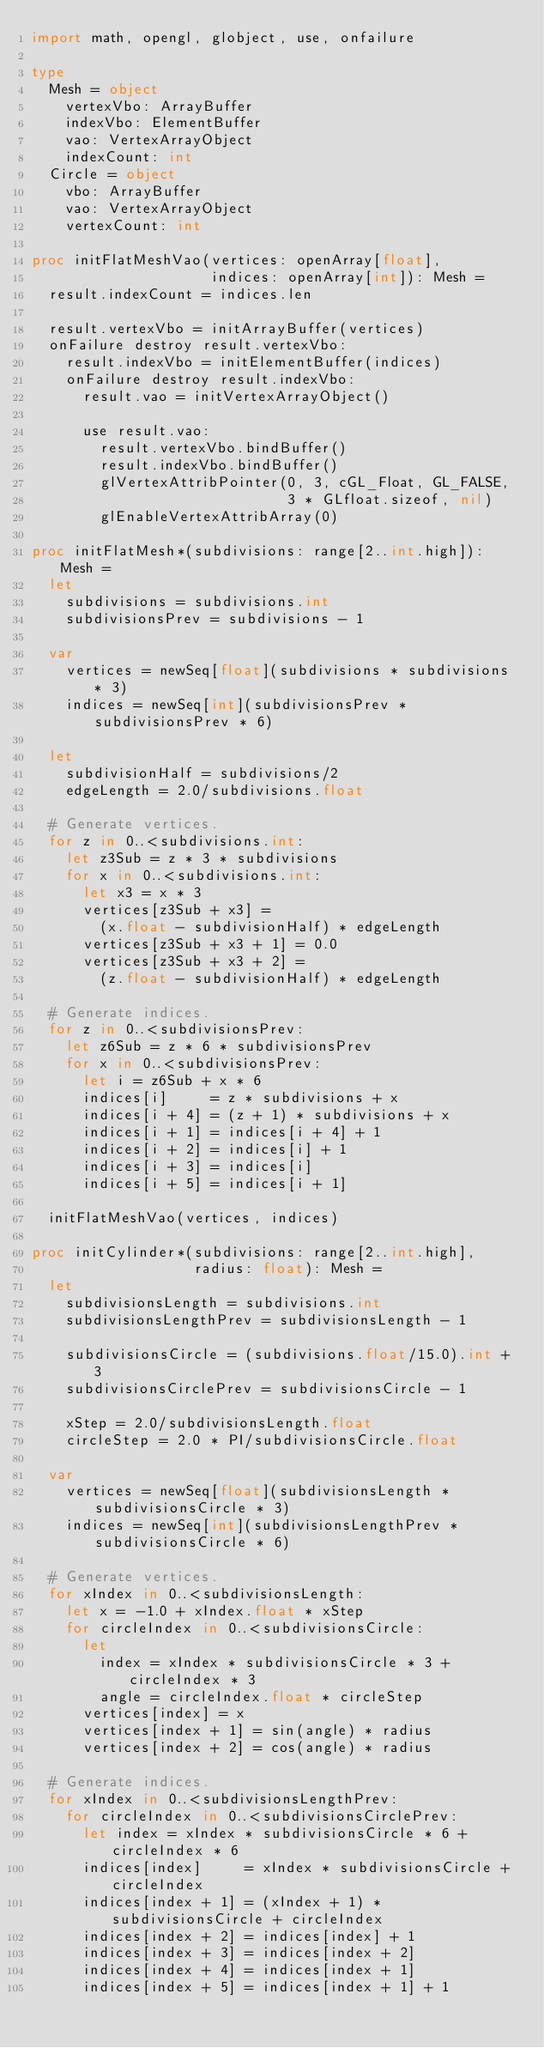Convert code to text. <code><loc_0><loc_0><loc_500><loc_500><_Nim_>import math, opengl, globject, use, onfailure

type
  Mesh = object
    vertexVbo: ArrayBuffer
    indexVbo: ElementBuffer
    vao: VertexArrayObject
    indexCount: int
  Circle = object
    vbo: ArrayBuffer
    vao: VertexArrayObject
    vertexCount: int

proc initFlatMeshVao(vertices: openArray[float],
                     indices: openArray[int]): Mesh =
  result.indexCount = indices.len

  result.vertexVbo = initArrayBuffer(vertices)
  onFailure destroy result.vertexVbo:
    result.indexVbo = initElementBuffer(indices)
    onFailure destroy result.indexVbo:
      result.vao = initVertexArrayObject()

      use result.vao:
        result.vertexVbo.bindBuffer()
        result.indexVbo.bindBuffer()
        glVertexAttribPointer(0, 3, cGL_Float, GL_FALSE,
                              3 * GLfloat.sizeof, nil)
        glEnableVertexAttribArray(0)

proc initFlatMesh*(subdivisions: range[2..int.high]): Mesh =
  let
    subdivisions = subdivisions.int
    subdivisionsPrev = subdivisions - 1

  var
    vertices = newSeq[float](subdivisions * subdivisions * 3)
    indices = newSeq[int](subdivisionsPrev * subdivisionsPrev * 6)

  let
    subdivisionHalf = subdivisions/2
    edgeLength = 2.0/subdivisions.float

  # Generate vertices.
  for z in 0..<subdivisions.int:
    let z3Sub = z * 3 * subdivisions
    for x in 0..<subdivisions.int:
      let x3 = x * 3
      vertices[z3Sub + x3] =
        (x.float - subdivisionHalf) * edgeLength
      vertices[z3Sub + x3 + 1] = 0.0
      vertices[z3Sub + x3 + 2] =
        (z.float - subdivisionHalf) * edgeLength

  # Generate indices.
  for z in 0..<subdivisionsPrev:
    let z6Sub = z * 6 * subdivisionsPrev
    for x in 0..<subdivisionsPrev:
      let i = z6Sub + x * 6
      indices[i]     = z * subdivisions + x
      indices[i + 4] = (z + 1) * subdivisions + x
      indices[i + 1] = indices[i + 4] + 1
      indices[i + 2] = indices[i] + 1
      indices[i + 3] = indices[i]
      indices[i + 5] = indices[i + 1]

  initFlatMeshVao(vertices, indices)

proc initCylinder*(subdivisions: range[2..int.high],
                   radius: float): Mesh =
  let
    subdivisionsLength = subdivisions.int
    subdivisionsLengthPrev = subdivisionsLength - 1

    subdivisionsCircle = (subdivisions.float/15.0).int + 3
    subdivisionsCirclePrev = subdivisionsCircle - 1

    xStep = 2.0/subdivisionsLength.float
    circleStep = 2.0 * PI/subdivisionsCircle.float

  var
    vertices = newSeq[float](subdivisionsLength * subdivisionsCircle * 3)
    indices = newSeq[int](subdivisionsLengthPrev * subdivisionsCircle * 6)

  # Generate vertices.
  for xIndex in 0..<subdivisionsLength:
    let x = -1.0 + xIndex.float * xStep
    for circleIndex in 0..<subdivisionsCircle:
      let
        index = xIndex * subdivisionsCircle * 3 + circleIndex * 3
        angle = circleIndex.float * circleStep
      vertices[index] = x
      vertices[index + 1] = sin(angle) * radius
      vertices[index + 2] = cos(angle) * radius

  # Generate indices.
  for xIndex in 0..<subdivisionsLengthPrev:
    for circleIndex in 0..<subdivisionsCirclePrev:
      let index = xIndex * subdivisionsCircle * 6 + circleIndex * 6
      indices[index]     = xIndex * subdivisionsCircle + circleIndex
      indices[index + 1] = (xIndex + 1) * subdivisionsCircle + circleIndex
      indices[index + 2] = indices[index] + 1
      indices[index + 3] = indices[index + 2]
      indices[index + 4] = indices[index + 1]
      indices[index + 5] = indices[index + 1] + 1
</code> 